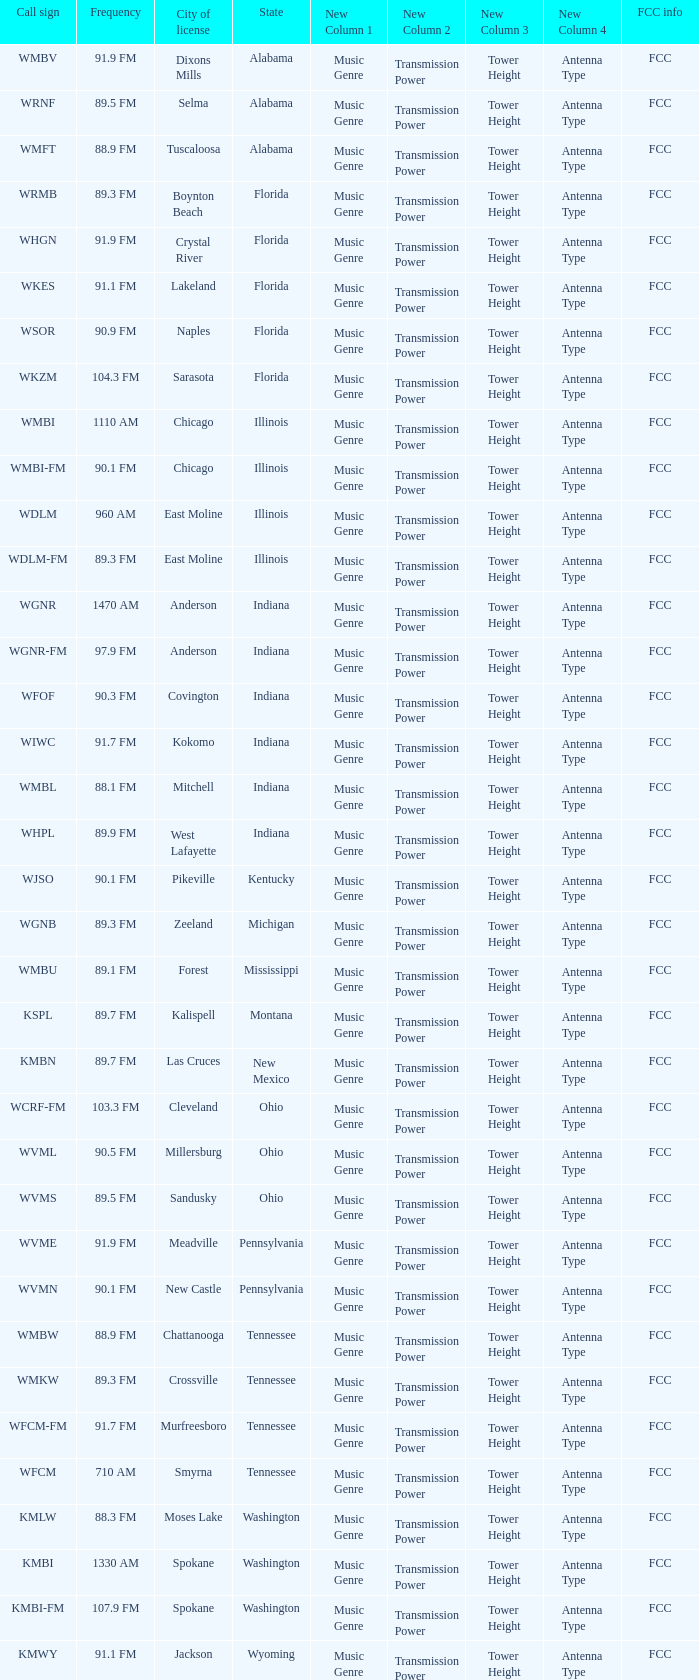What state is the radio station in that has a frequency of 90.1 FM and a city license in New Castle? Pennsylvania. 